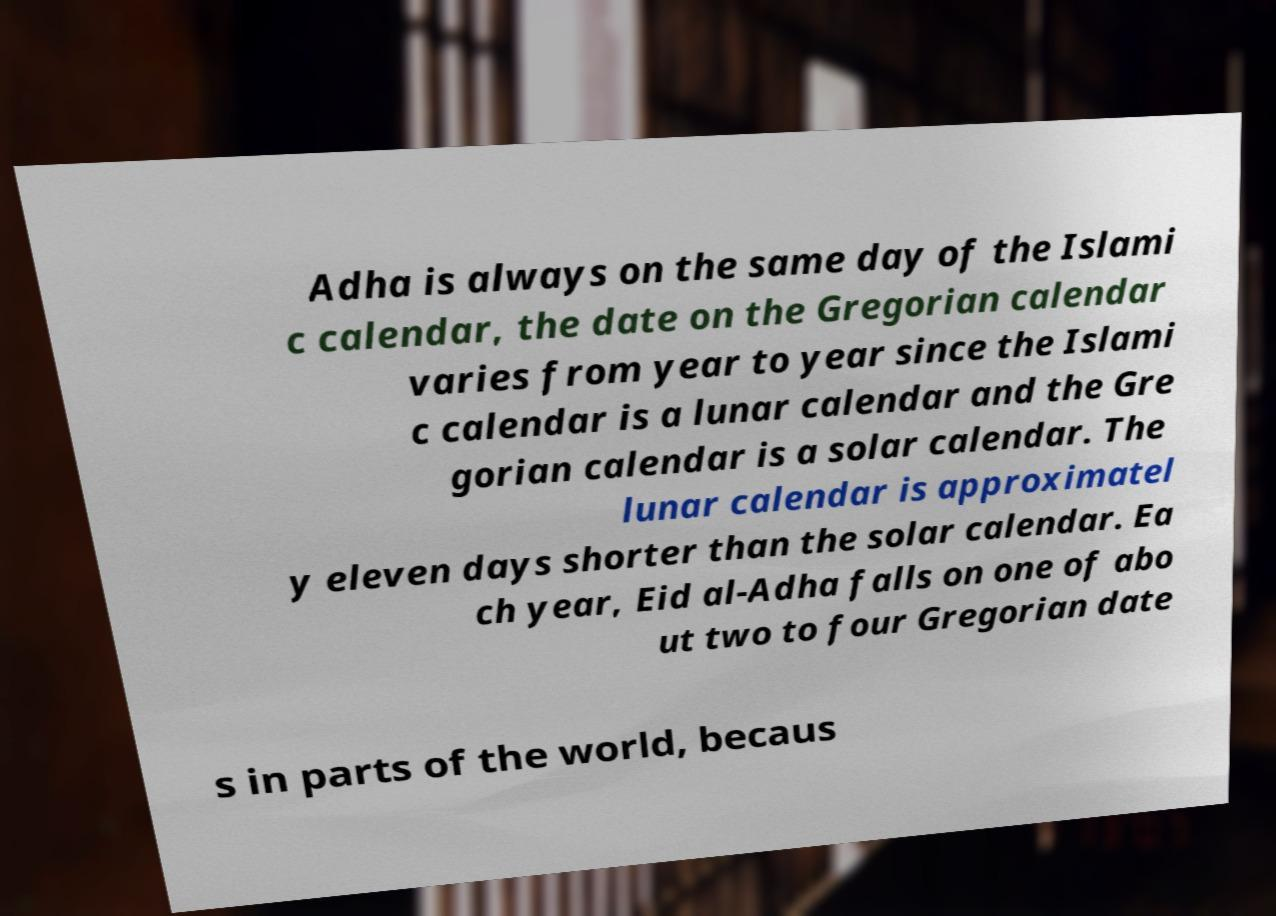Could you assist in decoding the text presented in this image and type it out clearly? Adha is always on the same day of the Islami c calendar, the date on the Gregorian calendar varies from year to year since the Islami c calendar is a lunar calendar and the Gre gorian calendar is a solar calendar. The lunar calendar is approximatel y eleven days shorter than the solar calendar. Ea ch year, Eid al-Adha falls on one of abo ut two to four Gregorian date s in parts of the world, becaus 